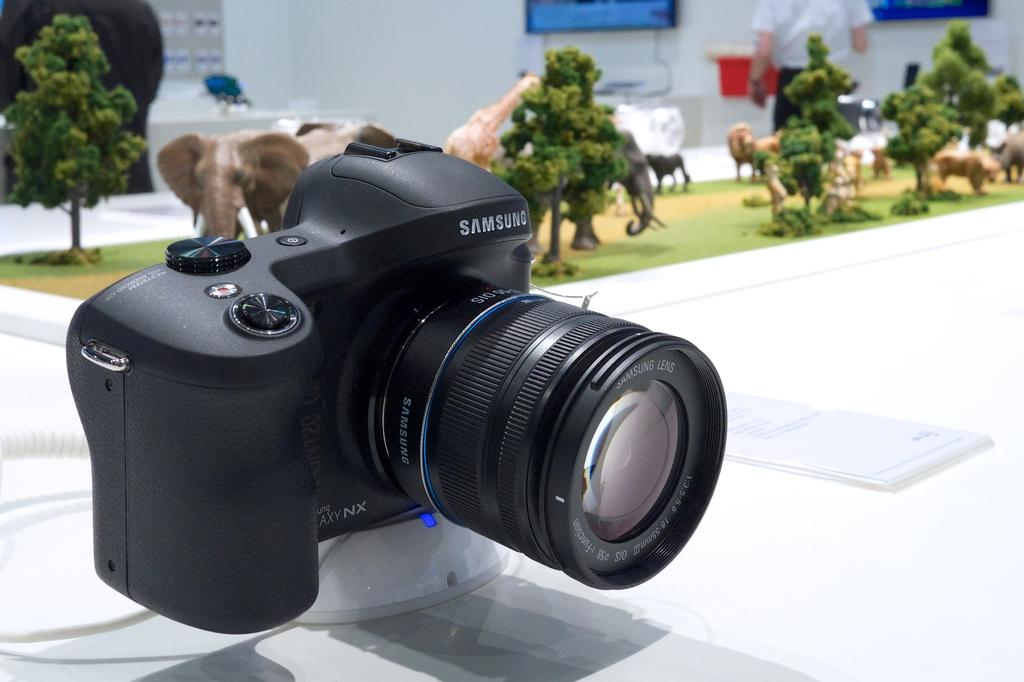What is the main subject of the image? The main subject of the image is a camera. Where is the camera placed in the image? The camera is on an object in the image. What type of objects can be seen in the image besides the camera? There are toys of animals and plants visible in the image. What type of natural elements can be seen in the image? There are trees visible in the image. How would you describe the background of the image? The background of the image is blurred. Can you identify any other people in the image besides the camera operator? Yes, there is a person visible in the background of the image. What type of structure is present in the background? There is a wall in the background of the image. What direction is the ink flowing in the image? There is no ink present in the image, so it cannot be determined in which direction it might be flowing. 